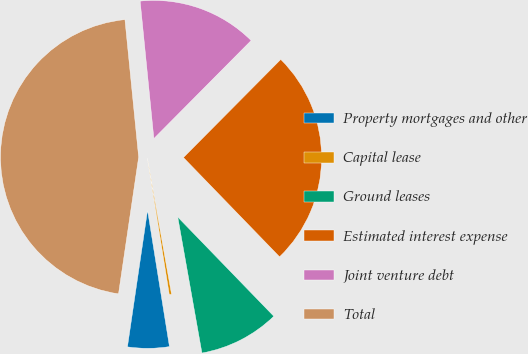Convert chart. <chart><loc_0><loc_0><loc_500><loc_500><pie_chart><fcel>Property mortgages and other<fcel>Capital lease<fcel>Ground leases<fcel>Estimated interest expense<fcel>Joint venture debt<fcel>Total<nl><fcel>4.86%<fcel>0.27%<fcel>9.44%<fcel>25.32%<fcel>14.02%<fcel>46.09%<nl></chart> 